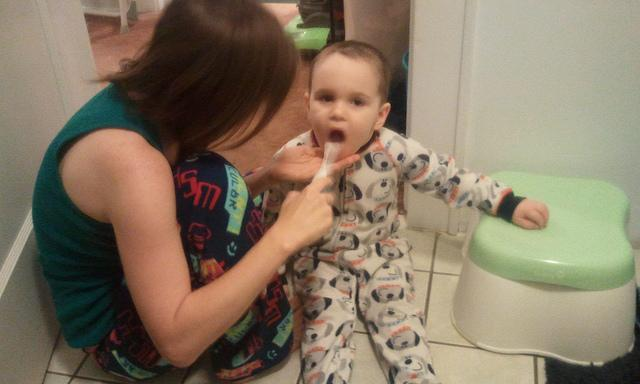What is the woman helping the child do? brush teeth 